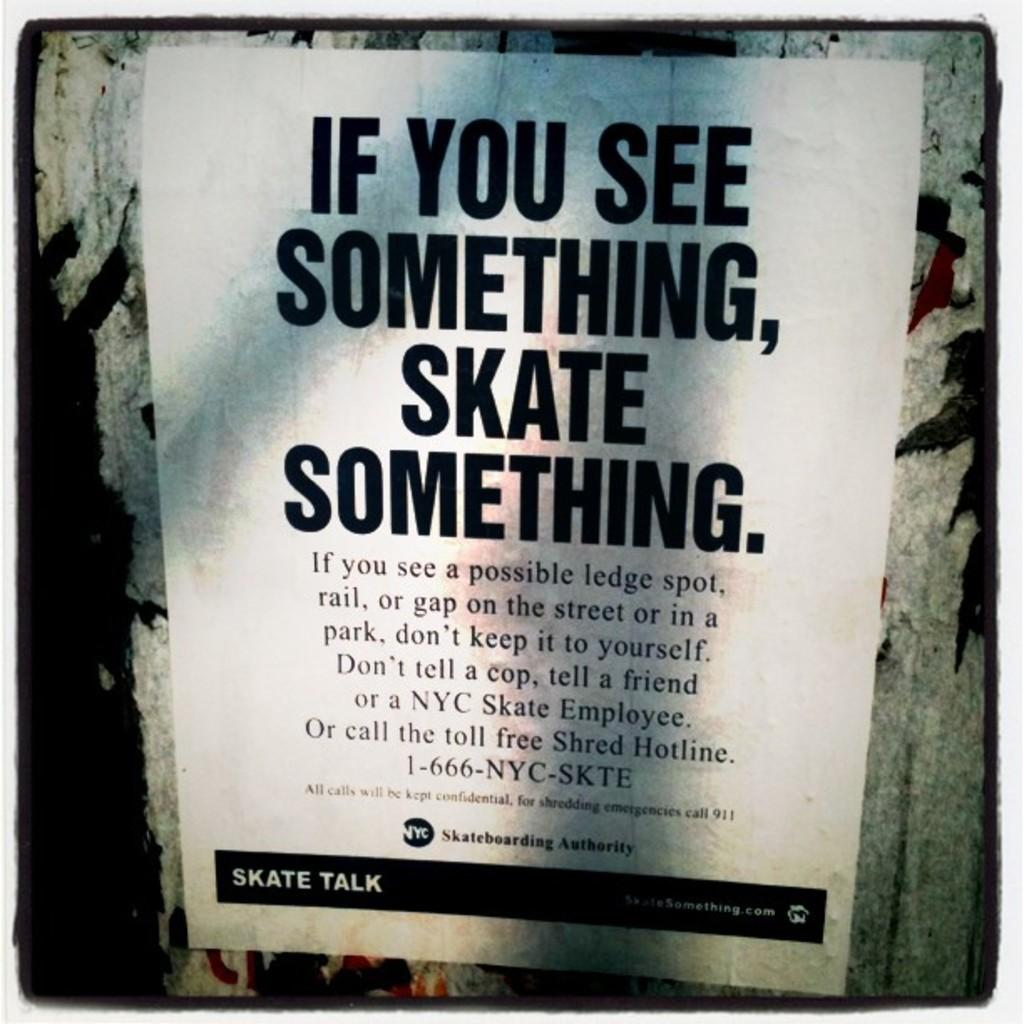<image>
Provide a brief description of the given image. A printed page that is stuck against a wall that is about skating. 